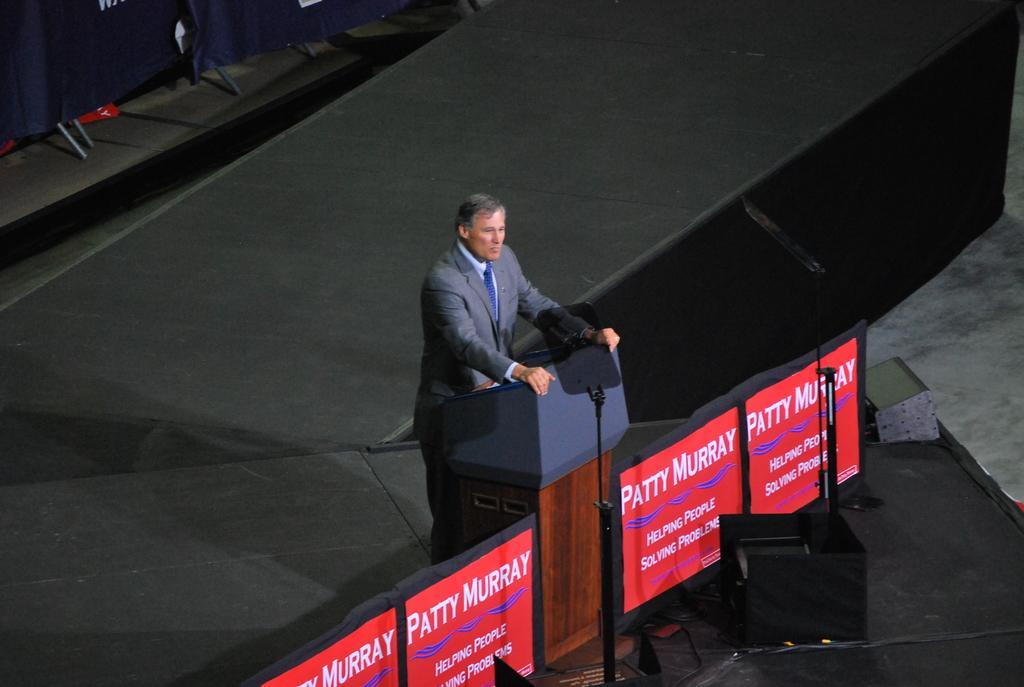How would you summarize this image in a sentence or two? In the center of the image we can see a man standing, before him there is a podium. On the right there is a speaker and we can see boards. At the bottom there is carpet. 